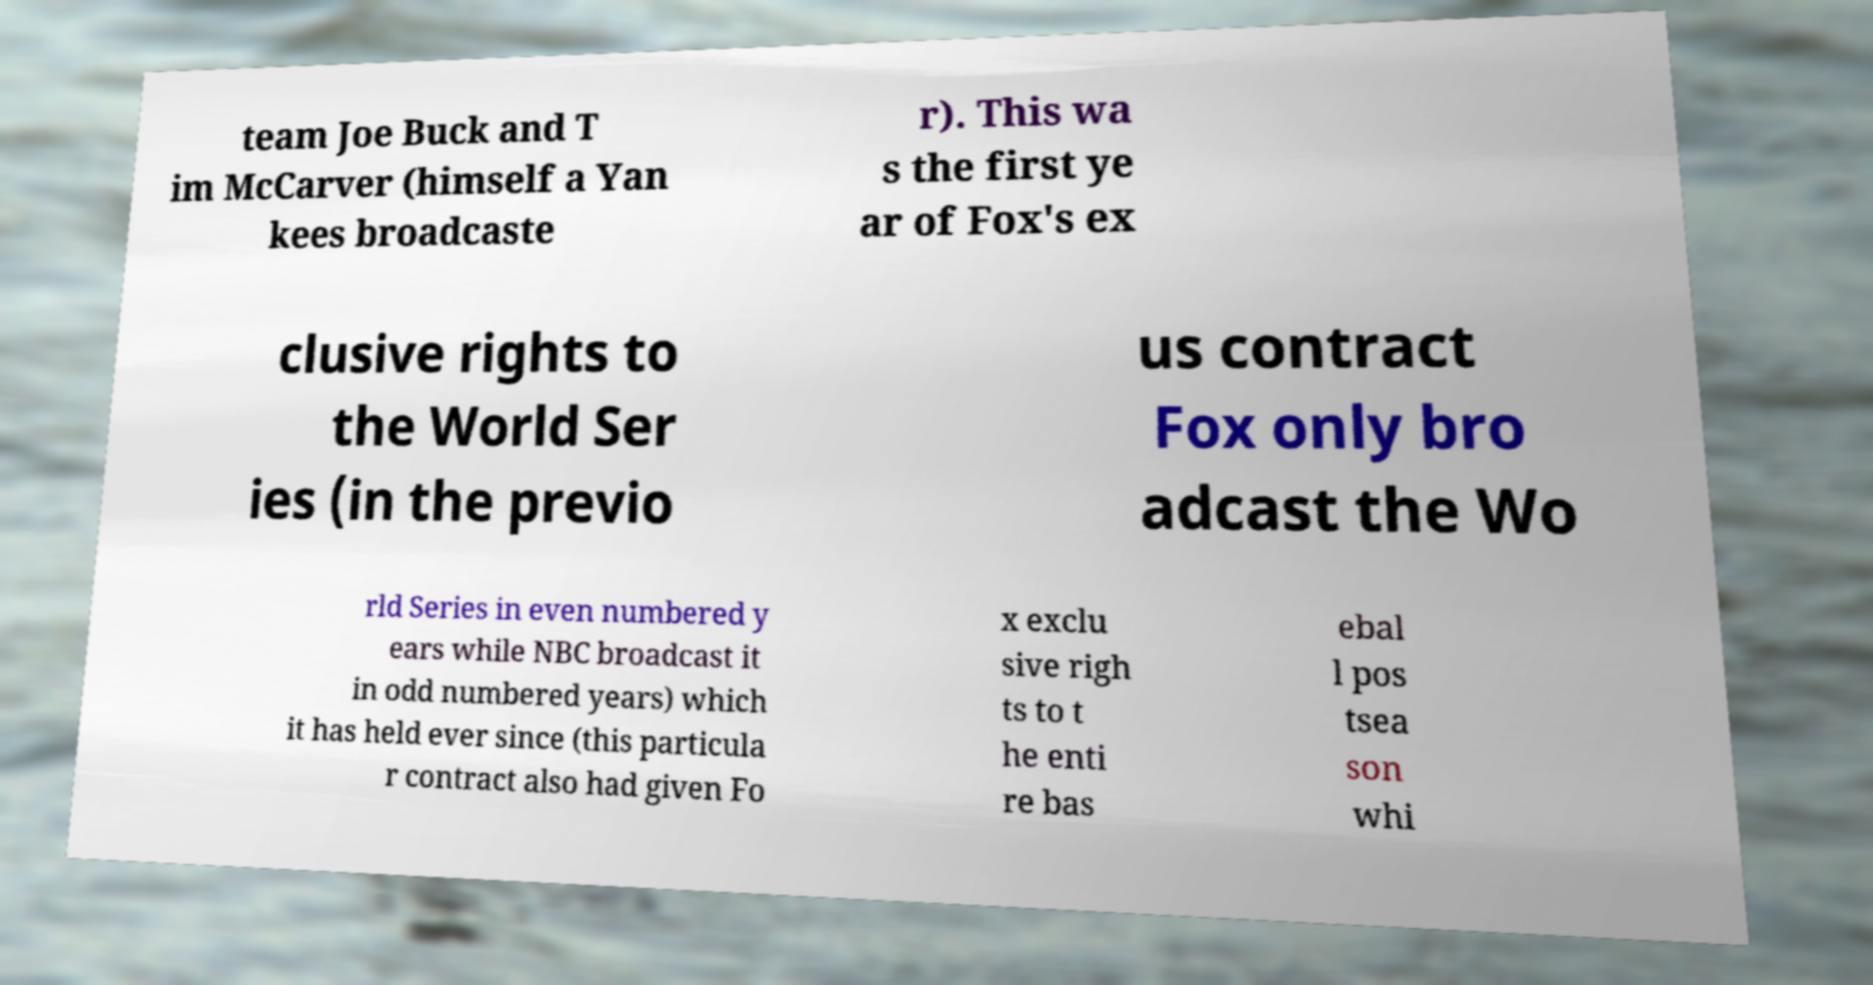Could you assist in decoding the text presented in this image and type it out clearly? team Joe Buck and T im McCarver (himself a Yan kees broadcaste r). This wa s the first ye ar of Fox's ex clusive rights to the World Ser ies (in the previo us contract Fox only bro adcast the Wo rld Series in even numbered y ears while NBC broadcast it in odd numbered years) which it has held ever since (this particula r contract also had given Fo x exclu sive righ ts to t he enti re bas ebal l pos tsea son whi 